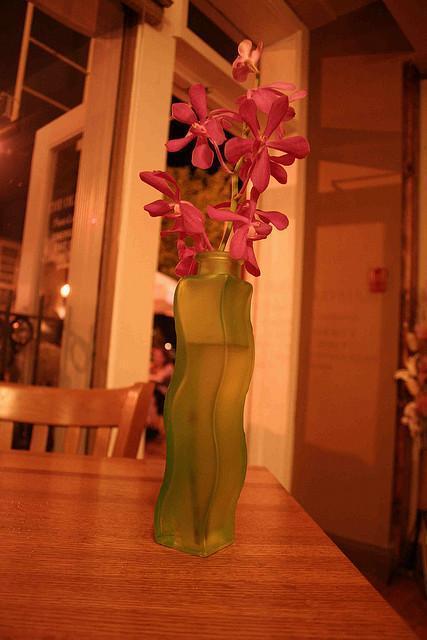How many chairs are visible?
Give a very brief answer. 1. How many dogs are on the bed?
Give a very brief answer. 0. 